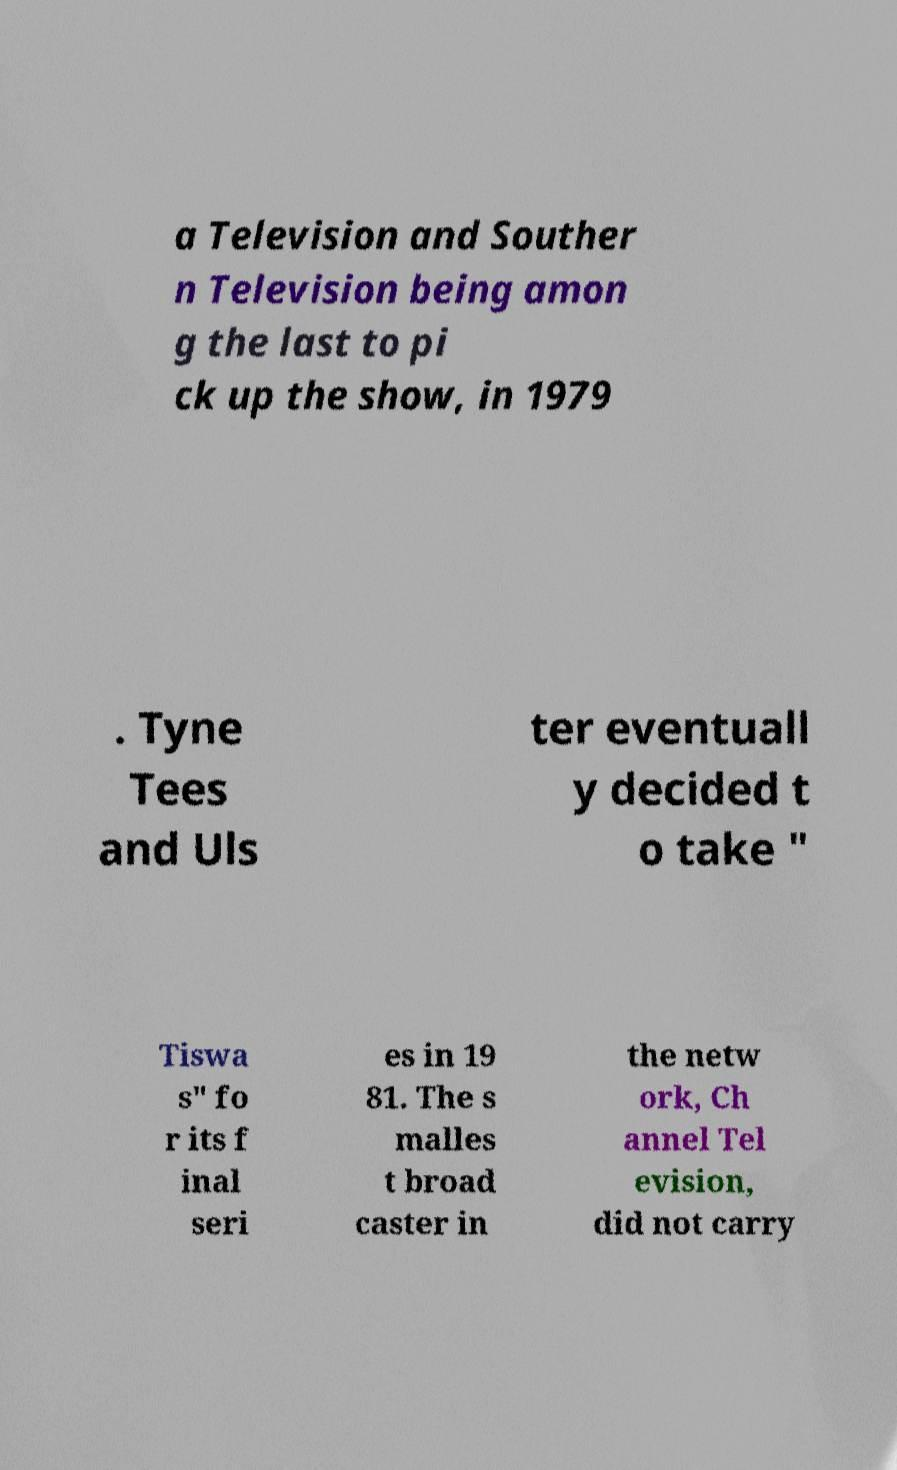Please identify and transcribe the text found in this image. a Television and Souther n Television being amon g the last to pi ck up the show, in 1979 . Tyne Tees and Uls ter eventuall y decided t o take " Tiswa s" fo r its f inal seri es in 19 81. The s malles t broad caster in the netw ork, Ch annel Tel evision, did not carry 